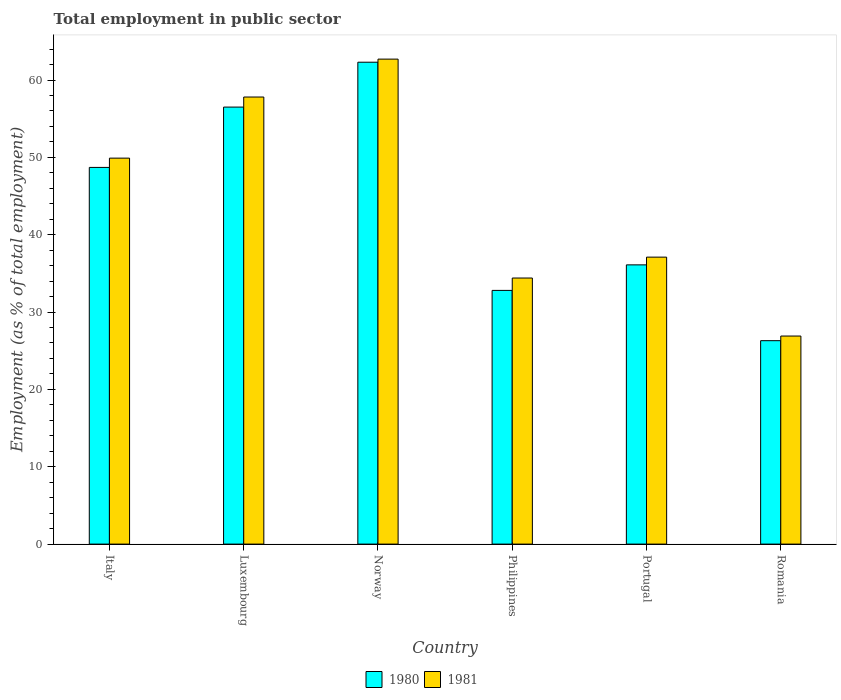How many different coloured bars are there?
Make the answer very short. 2. How many groups of bars are there?
Ensure brevity in your answer.  6. Are the number of bars per tick equal to the number of legend labels?
Your response must be concise. Yes. Are the number of bars on each tick of the X-axis equal?
Your answer should be compact. Yes. How many bars are there on the 6th tick from the right?
Make the answer very short. 2. What is the label of the 1st group of bars from the left?
Your response must be concise. Italy. In how many cases, is the number of bars for a given country not equal to the number of legend labels?
Give a very brief answer. 0. What is the employment in public sector in 1981 in Philippines?
Your response must be concise. 34.4. Across all countries, what is the maximum employment in public sector in 1980?
Give a very brief answer. 62.3. Across all countries, what is the minimum employment in public sector in 1980?
Make the answer very short. 26.3. In which country was the employment in public sector in 1981 maximum?
Provide a short and direct response. Norway. In which country was the employment in public sector in 1981 minimum?
Keep it short and to the point. Romania. What is the total employment in public sector in 1980 in the graph?
Provide a succinct answer. 262.7. What is the difference between the employment in public sector in 1981 in Luxembourg and that in Norway?
Give a very brief answer. -4.9. What is the difference between the employment in public sector in 1981 in Luxembourg and the employment in public sector in 1980 in Norway?
Ensure brevity in your answer.  -4.5. What is the average employment in public sector in 1980 per country?
Your answer should be very brief. 43.78. What is the difference between the employment in public sector of/in 1980 and employment in public sector of/in 1981 in Portugal?
Your response must be concise. -1. What is the ratio of the employment in public sector in 1980 in Portugal to that in Romania?
Give a very brief answer. 1.37. Is the employment in public sector in 1980 in Luxembourg less than that in Portugal?
Your answer should be very brief. No. What is the difference between the highest and the second highest employment in public sector in 1980?
Your response must be concise. 7.8. What is the difference between the highest and the lowest employment in public sector in 1980?
Offer a terse response. 36. In how many countries, is the employment in public sector in 1980 greater than the average employment in public sector in 1980 taken over all countries?
Offer a terse response. 3. Is the sum of the employment in public sector in 1981 in Italy and Luxembourg greater than the maximum employment in public sector in 1980 across all countries?
Your answer should be very brief. Yes. What does the 1st bar from the left in Philippines represents?
Your answer should be very brief. 1980. Are all the bars in the graph horizontal?
Your response must be concise. No. Are the values on the major ticks of Y-axis written in scientific E-notation?
Provide a short and direct response. No. Does the graph contain any zero values?
Provide a succinct answer. No. Does the graph contain grids?
Provide a short and direct response. No. Where does the legend appear in the graph?
Keep it short and to the point. Bottom center. How many legend labels are there?
Your answer should be compact. 2. What is the title of the graph?
Offer a very short reply. Total employment in public sector. What is the label or title of the Y-axis?
Give a very brief answer. Employment (as % of total employment). What is the Employment (as % of total employment) of 1980 in Italy?
Ensure brevity in your answer.  48.7. What is the Employment (as % of total employment) of 1981 in Italy?
Your response must be concise. 49.9. What is the Employment (as % of total employment) in 1980 in Luxembourg?
Give a very brief answer. 56.5. What is the Employment (as % of total employment) in 1981 in Luxembourg?
Keep it short and to the point. 57.8. What is the Employment (as % of total employment) of 1980 in Norway?
Offer a very short reply. 62.3. What is the Employment (as % of total employment) in 1981 in Norway?
Your response must be concise. 62.7. What is the Employment (as % of total employment) of 1980 in Philippines?
Your response must be concise. 32.8. What is the Employment (as % of total employment) of 1981 in Philippines?
Your answer should be very brief. 34.4. What is the Employment (as % of total employment) in 1980 in Portugal?
Your answer should be compact. 36.1. What is the Employment (as % of total employment) in 1981 in Portugal?
Provide a succinct answer. 37.1. What is the Employment (as % of total employment) in 1980 in Romania?
Your response must be concise. 26.3. What is the Employment (as % of total employment) in 1981 in Romania?
Make the answer very short. 26.9. Across all countries, what is the maximum Employment (as % of total employment) in 1980?
Your answer should be compact. 62.3. Across all countries, what is the maximum Employment (as % of total employment) of 1981?
Your answer should be compact. 62.7. Across all countries, what is the minimum Employment (as % of total employment) in 1980?
Provide a succinct answer. 26.3. Across all countries, what is the minimum Employment (as % of total employment) in 1981?
Make the answer very short. 26.9. What is the total Employment (as % of total employment) in 1980 in the graph?
Give a very brief answer. 262.7. What is the total Employment (as % of total employment) in 1981 in the graph?
Your answer should be very brief. 268.8. What is the difference between the Employment (as % of total employment) of 1981 in Italy and that in Luxembourg?
Provide a succinct answer. -7.9. What is the difference between the Employment (as % of total employment) of 1981 in Italy and that in Norway?
Keep it short and to the point. -12.8. What is the difference between the Employment (as % of total employment) of 1980 in Italy and that in Romania?
Ensure brevity in your answer.  22.4. What is the difference between the Employment (as % of total employment) in 1980 in Luxembourg and that in Philippines?
Ensure brevity in your answer.  23.7. What is the difference between the Employment (as % of total employment) in 1981 in Luxembourg and that in Philippines?
Your answer should be compact. 23.4. What is the difference between the Employment (as % of total employment) in 1980 in Luxembourg and that in Portugal?
Offer a very short reply. 20.4. What is the difference between the Employment (as % of total employment) in 1981 in Luxembourg and that in Portugal?
Ensure brevity in your answer.  20.7. What is the difference between the Employment (as % of total employment) in 1980 in Luxembourg and that in Romania?
Give a very brief answer. 30.2. What is the difference between the Employment (as % of total employment) of 1981 in Luxembourg and that in Romania?
Offer a very short reply. 30.9. What is the difference between the Employment (as % of total employment) in 1980 in Norway and that in Philippines?
Offer a very short reply. 29.5. What is the difference between the Employment (as % of total employment) of 1981 in Norway and that in Philippines?
Offer a very short reply. 28.3. What is the difference between the Employment (as % of total employment) of 1980 in Norway and that in Portugal?
Ensure brevity in your answer.  26.2. What is the difference between the Employment (as % of total employment) of 1981 in Norway and that in Portugal?
Ensure brevity in your answer.  25.6. What is the difference between the Employment (as % of total employment) of 1980 in Norway and that in Romania?
Give a very brief answer. 36. What is the difference between the Employment (as % of total employment) in 1981 in Norway and that in Romania?
Provide a short and direct response. 35.8. What is the difference between the Employment (as % of total employment) in 1980 in Philippines and that in Portugal?
Your response must be concise. -3.3. What is the difference between the Employment (as % of total employment) in 1980 in Philippines and that in Romania?
Make the answer very short. 6.5. What is the difference between the Employment (as % of total employment) in 1981 in Portugal and that in Romania?
Your response must be concise. 10.2. What is the difference between the Employment (as % of total employment) in 1980 in Italy and the Employment (as % of total employment) in 1981 in Philippines?
Keep it short and to the point. 14.3. What is the difference between the Employment (as % of total employment) in 1980 in Italy and the Employment (as % of total employment) in 1981 in Romania?
Your answer should be compact. 21.8. What is the difference between the Employment (as % of total employment) of 1980 in Luxembourg and the Employment (as % of total employment) of 1981 in Philippines?
Keep it short and to the point. 22.1. What is the difference between the Employment (as % of total employment) in 1980 in Luxembourg and the Employment (as % of total employment) in 1981 in Portugal?
Make the answer very short. 19.4. What is the difference between the Employment (as % of total employment) in 1980 in Luxembourg and the Employment (as % of total employment) in 1981 in Romania?
Give a very brief answer. 29.6. What is the difference between the Employment (as % of total employment) of 1980 in Norway and the Employment (as % of total employment) of 1981 in Philippines?
Offer a terse response. 27.9. What is the difference between the Employment (as % of total employment) in 1980 in Norway and the Employment (as % of total employment) in 1981 in Portugal?
Keep it short and to the point. 25.2. What is the difference between the Employment (as % of total employment) in 1980 in Norway and the Employment (as % of total employment) in 1981 in Romania?
Offer a terse response. 35.4. What is the difference between the Employment (as % of total employment) in 1980 in Philippines and the Employment (as % of total employment) in 1981 in Portugal?
Make the answer very short. -4.3. What is the difference between the Employment (as % of total employment) in 1980 in Philippines and the Employment (as % of total employment) in 1981 in Romania?
Make the answer very short. 5.9. What is the difference between the Employment (as % of total employment) in 1980 in Portugal and the Employment (as % of total employment) in 1981 in Romania?
Provide a short and direct response. 9.2. What is the average Employment (as % of total employment) in 1980 per country?
Keep it short and to the point. 43.78. What is the average Employment (as % of total employment) of 1981 per country?
Offer a very short reply. 44.8. What is the difference between the Employment (as % of total employment) in 1980 and Employment (as % of total employment) in 1981 in Philippines?
Provide a short and direct response. -1.6. What is the difference between the Employment (as % of total employment) in 1980 and Employment (as % of total employment) in 1981 in Portugal?
Keep it short and to the point. -1. What is the difference between the Employment (as % of total employment) of 1980 and Employment (as % of total employment) of 1981 in Romania?
Give a very brief answer. -0.6. What is the ratio of the Employment (as % of total employment) of 1980 in Italy to that in Luxembourg?
Make the answer very short. 0.86. What is the ratio of the Employment (as % of total employment) in 1981 in Italy to that in Luxembourg?
Your answer should be very brief. 0.86. What is the ratio of the Employment (as % of total employment) in 1980 in Italy to that in Norway?
Offer a terse response. 0.78. What is the ratio of the Employment (as % of total employment) of 1981 in Italy to that in Norway?
Ensure brevity in your answer.  0.8. What is the ratio of the Employment (as % of total employment) in 1980 in Italy to that in Philippines?
Your answer should be very brief. 1.48. What is the ratio of the Employment (as % of total employment) in 1981 in Italy to that in Philippines?
Give a very brief answer. 1.45. What is the ratio of the Employment (as % of total employment) in 1980 in Italy to that in Portugal?
Keep it short and to the point. 1.35. What is the ratio of the Employment (as % of total employment) of 1981 in Italy to that in Portugal?
Provide a succinct answer. 1.34. What is the ratio of the Employment (as % of total employment) in 1980 in Italy to that in Romania?
Offer a very short reply. 1.85. What is the ratio of the Employment (as % of total employment) in 1981 in Italy to that in Romania?
Your answer should be very brief. 1.85. What is the ratio of the Employment (as % of total employment) of 1980 in Luxembourg to that in Norway?
Your answer should be compact. 0.91. What is the ratio of the Employment (as % of total employment) of 1981 in Luxembourg to that in Norway?
Ensure brevity in your answer.  0.92. What is the ratio of the Employment (as % of total employment) in 1980 in Luxembourg to that in Philippines?
Make the answer very short. 1.72. What is the ratio of the Employment (as % of total employment) of 1981 in Luxembourg to that in Philippines?
Ensure brevity in your answer.  1.68. What is the ratio of the Employment (as % of total employment) in 1980 in Luxembourg to that in Portugal?
Provide a short and direct response. 1.57. What is the ratio of the Employment (as % of total employment) of 1981 in Luxembourg to that in Portugal?
Your answer should be very brief. 1.56. What is the ratio of the Employment (as % of total employment) in 1980 in Luxembourg to that in Romania?
Provide a short and direct response. 2.15. What is the ratio of the Employment (as % of total employment) in 1981 in Luxembourg to that in Romania?
Provide a short and direct response. 2.15. What is the ratio of the Employment (as % of total employment) in 1980 in Norway to that in Philippines?
Your answer should be very brief. 1.9. What is the ratio of the Employment (as % of total employment) of 1981 in Norway to that in Philippines?
Offer a very short reply. 1.82. What is the ratio of the Employment (as % of total employment) in 1980 in Norway to that in Portugal?
Ensure brevity in your answer.  1.73. What is the ratio of the Employment (as % of total employment) in 1981 in Norway to that in Portugal?
Your response must be concise. 1.69. What is the ratio of the Employment (as % of total employment) in 1980 in Norway to that in Romania?
Ensure brevity in your answer.  2.37. What is the ratio of the Employment (as % of total employment) in 1981 in Norway to that in Romania?
Offer a very short reply. 2.33. What is the ratio of the Employment (as % of total employment) in 1980 in Philippines to that in Portugal?
Give a very brief answer. 0.91. What is the ratio of the Employment (as % of total employment) of 1981 in Philippines to that in Portugal?
Ensure brevity in your answer.  0.93. What is the ratio of the Employment (as % of total employment) of 1980 in Philippines to that in Romania?
Your answer should be very brief. 1.25. What is the ratio of the Employment (as % of total employment) in 1981 in Philippines to that in Romania?
Give a very brief answer. 1.28. What is the ratio of the Employment (as % of total employment) in 1980 in Portugal to that in Romania?
Give a very brief answer. 1.37. What is the ratio of the Employment (as % of total employment) of 1981 in Portugal to that in Romania?
Provide a succinct answer. 1.38. What is the difference between the highest and the lowest Employment (as % of total employment) of 1981?
Offer a very short reply. 35.8. 